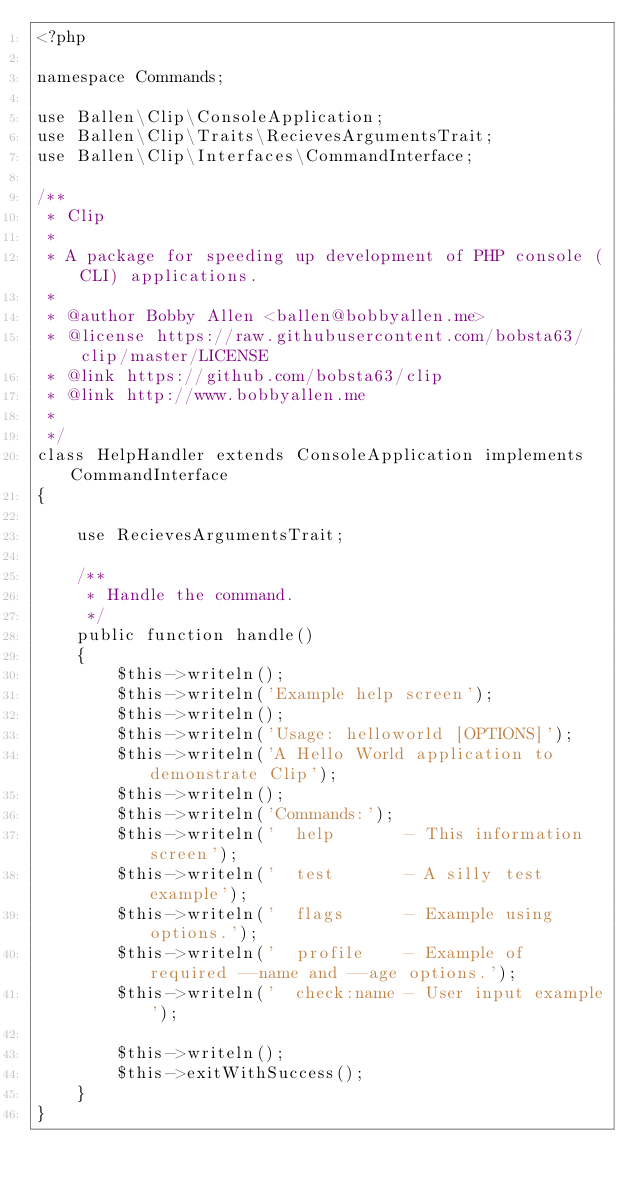Convert code to text. <code><loc_0><loc_0><loc_500><loc_500><_PHP_><?php

namespace Commands;

use Ballen\Clip\ConsoleApplication;
use Ballen\Clip\Traits\RecievesArgumentsTrait;
use Ballen\Clip\Interfaces\CommandInterface;

/**
 * Clip
 * 
 * A package for speeding up development of PHP console (CLI) applications.
 *
 * @author Bobby Allen <ballen@bobbyallen.me>
 * @license https://raw.githubusercontent.com/bobsta63/clip/master/LICENSE
 * @link https://github.com/bobsta63/clip
 * @link http://www.bobbyallen.me
 *
 */
class HelpHandler extends ConsoleApplication implements CommandInterface
{

    use RecievesArgumentsTrait;

    /**
     * Handle the command.
     */
    public function handle()
    {
        $this->writeln();
        $this->writeln('Example help screen');
        $this->writeln();
        $this->writeln('Usage: helloworld [OPTIONS]');
        $this->writeln('A Hello World application to demonstrate Clip');
        $this->writeln();
        $this->writeln('Commands:');
        $this->writeln('  help       - This information screen');
        $this->writeln('  test       - A silly test example');
        $this->writeln('  flags      - Example using options.');
        $this->writeln('  profile    - Example of required --name and --age options.');
        $this->writeln('  check:name - User input example');

        $this->writeln();
        $this->exitWithSuccess();
    }
}
</code> 